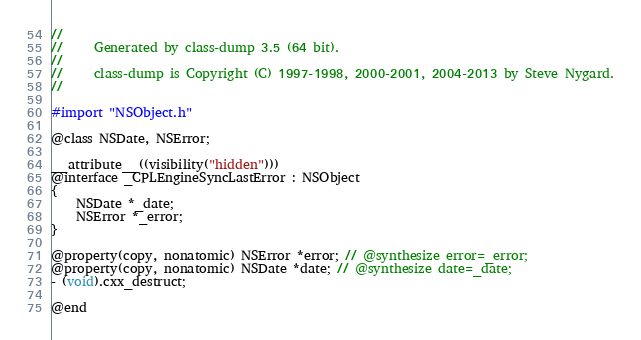Convert code to text. <code><loc_0><loc_0><loc_500><loc_500><_C_>//
//     Generated by class-dump 3.5 (64 bit).
//
//     class-dump is Copyright (C) 1997-1998, 2000-2001, 2004-2013 by Steve Nygard.
//

#import "NSObject.h"

@class NSDate, NSError;

__attribute__((visibility("hidden")))
@interface _CPLEngineSyncLastError : NSObject
{
    NSDate *_date;
    NSError *_error;
}

@property(copy, nonatomic) NSError *error; // @synthesize error=_error;
@property(copy, nonatomic) NSDate *date; // @synthesize date=_date;
- (void).cxx_destruct;

@end

</code> 